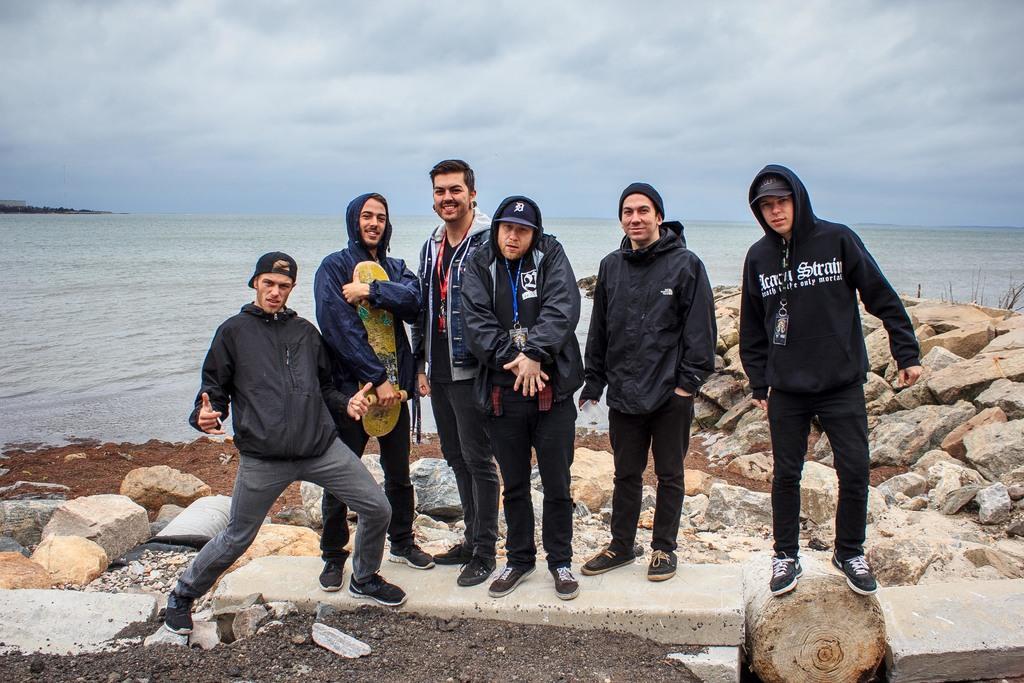Describe this image in one or two sentences. In this image, we can see some people standing, we can see some rocks and stones on the ground, in the background, there is a sea, at the top we can see the sky. 